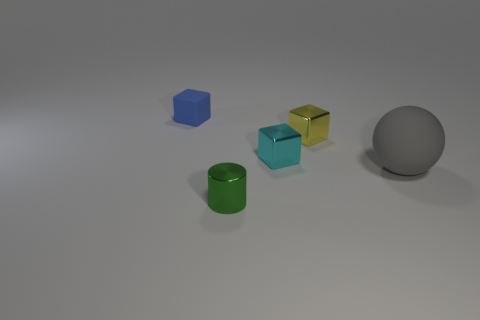Subtract 1 blocks. How many blocks are left? 2 Add 2 tiny green things. How many objects exist? 7 Subtract all blocks. How many objects are left? 2 Subtract all gray rubber balls. Subtract all small green cylinders. How many objects are left? 3 Add 2 small yellow blocks. How many small yellow blocks are left? 3 Add 4 yellow shiny objects. How many yellow shiny objects exist? 5 Subtract 0 brown cubes. How many objects are left? 5 